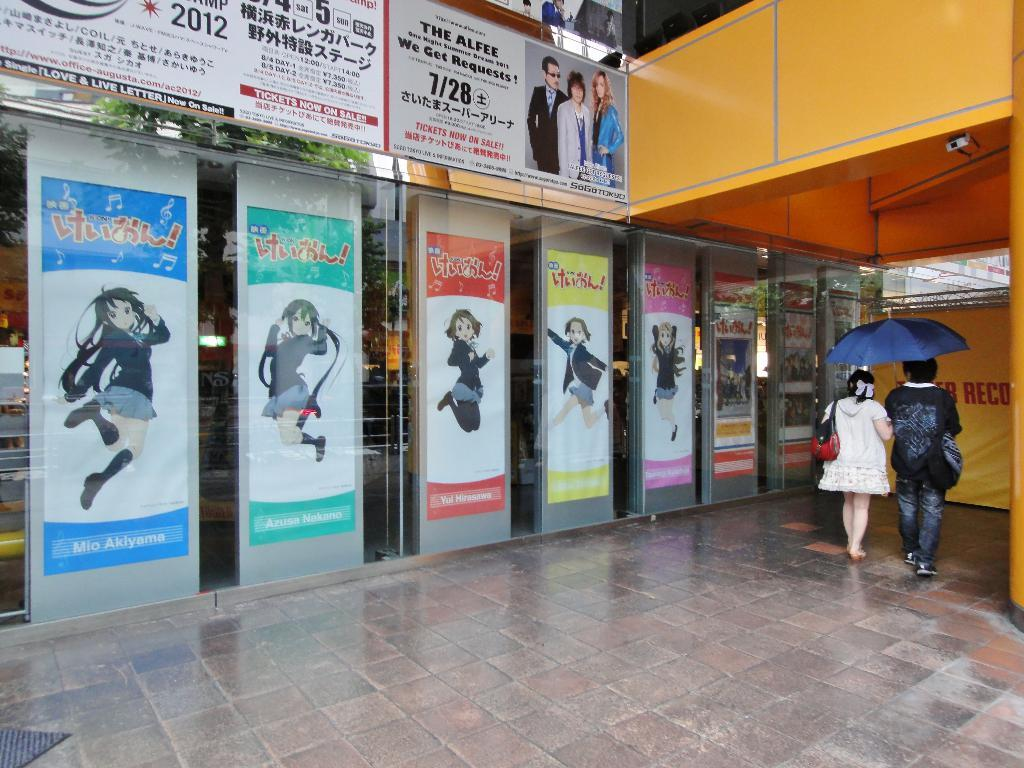What are the two persons in the image doing? The two persons are walking on the right side of the image. What object can be seen in the image that is used for protection from rain or sun? There is an umbrella in the image. What type of advertisements or announcements can be seen in the image? There are hoardings and posters in the image. What surface can be seen under the persons' feet in the image? The floor is visible in the image. Where is the faucet located in the image? There is no faucet present in the image. What type of cup is being used by the judge in the image? There is no judge or cup present in the image. 